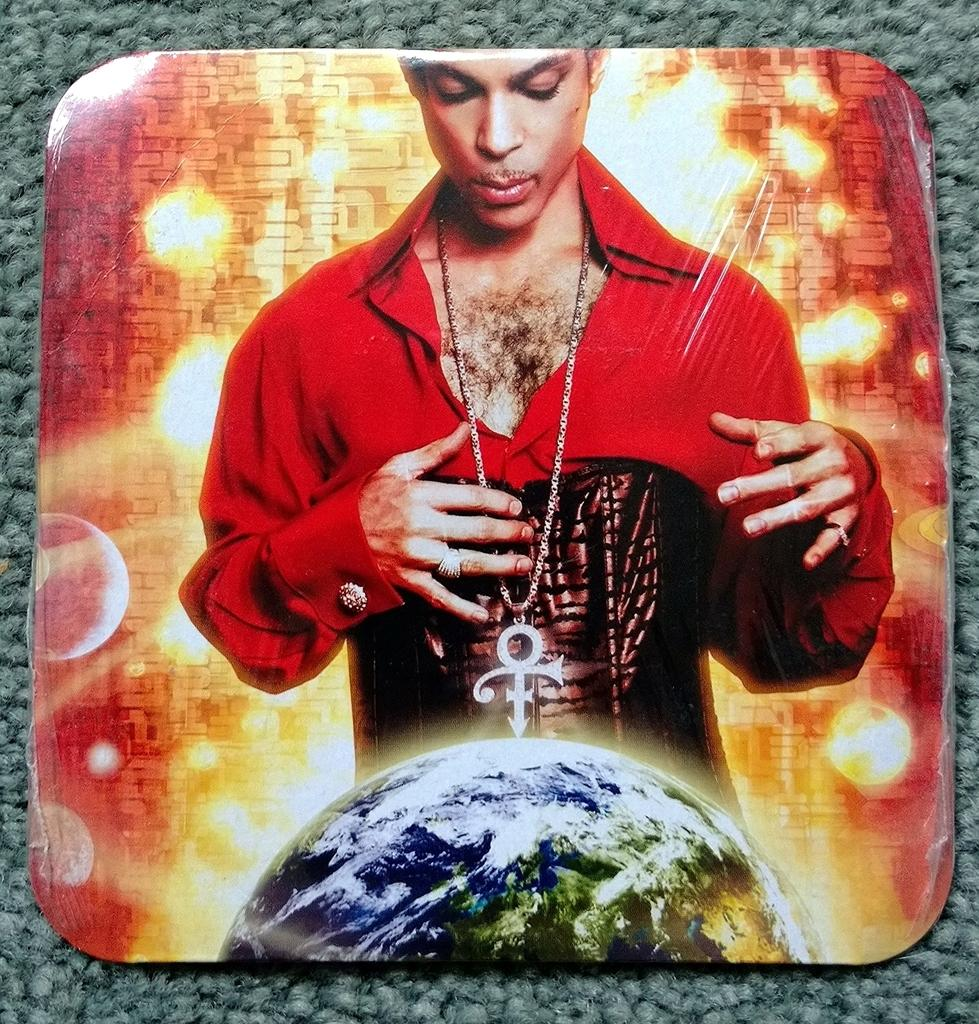What is the main subject of the image? There is a CD cover in the image. Is there anyone else present in the image besides the CD cover? Yes, there is a person in the image. What other object or element can be seen in the image? There is a planet in the image. How many bananas are hanging from the planet in the image? There are no bananas present in the image, and they are not hanging from the planet. 